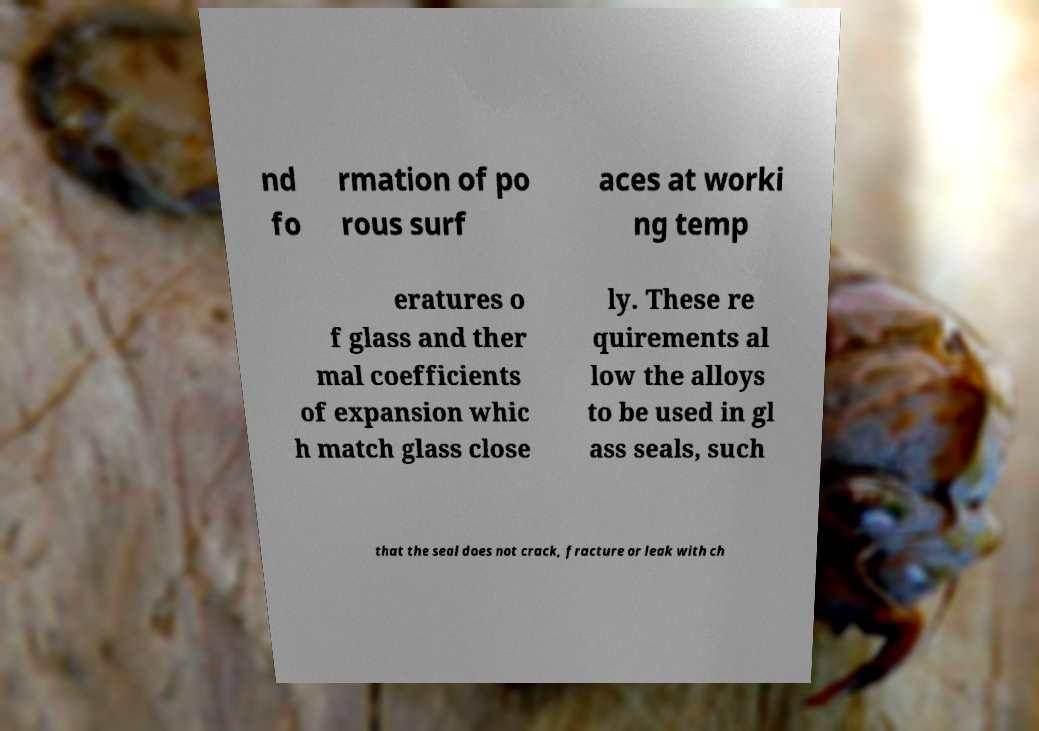Could you extract and type out the text from this image? nd fo rmation of po rous surf aces at worki ng temp eratures o f glass and ther mal coefficients of expansion whic h match glass close ly. These re quirements al low the alloys to be used in gl ass seals, such that the seal does not crack, fracture or leak with ch 